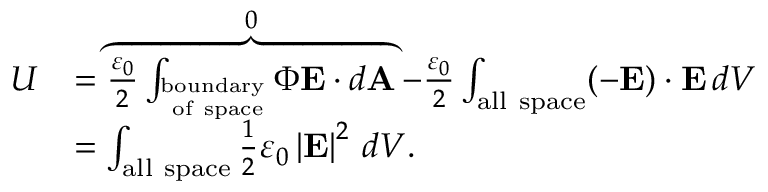<formula> <loc_0><loc_0><loc_500><loc_500>{ \begin{array} { r l } { U } & { = \overbrace { { \frac { \varepsilon _ { 0 } } { 2 } } \int _ { _ { o f s p a c e } ^ { b o u n d a r y } } \Phi E \cdot d A } ^ { 0 } - { \frac { \varepsilon _ { 0 } } { 2 } } \int _ { a l l s p a c e } ( - E ) \cdot E \, d V } \\ & { = \int _ { a l l s p a c e } { \frac { 1 } { 2 } } \varepsilon _ { 0 } \left | { E } \right | ^ { 2 } \, d V . } \end{array} }</formula> 